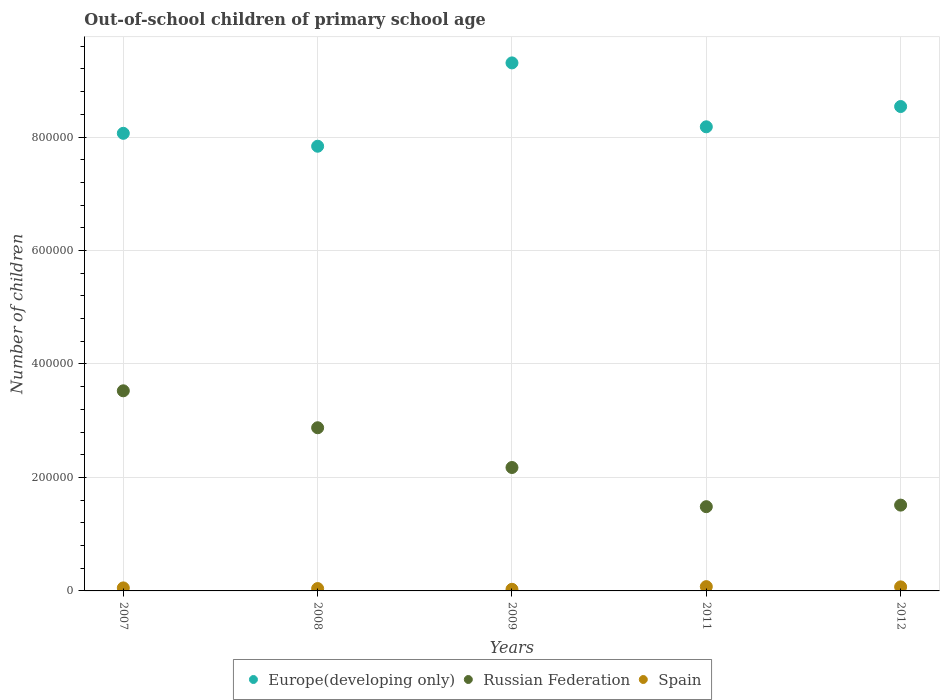How many different coloured dotlines are there?
Provide a short and direct response. 3. What is the number of out-of-school children in Russian Federation in 2007?
Give a very brief answer. 3.53e+05. Across all years, what is the maximum number of out-of-school children in Spain?
Your response must be concise. 7575. Across all years, what is the minimum number of out-of-school children in Spain?
Give a very brief answer. 2853. In which year was the number of out-of-school children in Europe(developing only) maximum?
Your response must be concise. 2009. In which year was the number of out-of-school children in Russian Federation minimum?
Make the answer very short. 2011. What is the total number of out-of-school children in Europe(developing only) in the graph?
Keep it short and to the point. 4.19e+06. What is the difference between the number of out-of-school children in Russian Federation in 2007 and that in 2012?
Your answer should be very brief. 2.01e+05. What is the difference between the number of out-of-school children in Russian Federation in 2009 and the number of out-of-school children in Spain in 2012?
Offer a terse response. 2.10e+05. What is the average number of out-of-school children in Russian Federation per year?
Offer a terse response. 2.32e+05. In the year 2012, what is the difference between the number of out-of-school children in Spain and number of out-of-school children in Russian Federation?
Give a very brief answer. -1.44e+05. In how many years, is the number of out-of-school children in Spain greater than 840000?
Your answer should be compact. 0. What is the ratio of the number of out-of-school children in Spain in 2008 to that in 2011?
Provide a short and direct response. 0.55. Is the number of out-of-school children in Russian Federation in 2009 less than that in 2011?
Your answer should be very brief. No. Is the difference between the number of out-of-school children in Spain in 2008 and 2012 greater than the difference between the number of out-of-school children in Russian Federation in 2008 and 2012?
Your answer should be very brief. No. What is the difference between the highest and the second highest number of out-of-school children in Russian Federation?
Ensure brevity in your answer.  6.51e+04. What is the difference between the highest and the lowest number of out-of-school children in Europe(developing only)?
Keep it short and to the point. 1.47e+05. In how many years, is the number of out-of-school children in Russian Federation greater than the average number of out-of-school children in Russian Federation taken over all years?
Keep it short and to the point. 2. Does the number of out-of-school children in Russian Federation monotonically increase over the years?
Your response must be concise. No. Is the number of out-of-school children in Russian Federation strictly greater than the number of out-of-school children in Spain over the years?
Keep it short and to the point. Yes. Is the number of out-of-school children in Europe(developing only) strictly less than the number of out-of-school children in Russian Federation over the years?
Your response must be concise. No. Are the values on the major ticks of Y-axis written in scientific E-notation?
Keep it short and to the point. No. Does the graph contain any zero values?
Your answer should be compact. No. How are the legend labels stacked?
Offer a very short reply. Horizontal. What is the title of the graph?
Your answer should be compact. Out-of-school children of primary school age. What is the label or title of the X-axis?
Offer a terse response. Years. What is the label or title of the Y-axis?
Offer a terse response. Number of children. What is the Number of children in Europe(developing only) in 2007?
Offer a very short reply. 8.07e+05. What is the Number of children in Russian Federation in 2007?
Provide a succinct answer. 3.53e+05. What is the Number of children of Spain in 2007?
Offer a terse response. 5316. What is the Number of children of Europe(developing only) in 2008?
Your answer should be compact. 7.84e+05. What is the Number of children in Russian Federation in 2008?
Provide a short and direct response. 2.88e+05. What is the Number of children of Spain in 2008?
Your answer should be very brief. 4170. What is the Number of children in Europe(developing only) in 2009?
Make the answer very short. 9.31e+05. What is the Number of children of Russian Federation in 2009?
Offer a terse response. 2.18e+05. What is the Number of children in Spain in 2009?
Offer a very short reply. 2853. What is the Number of children of Europe(developing only) in 2011?
Provide a succinct answer. 8.18e+05. What is the Number of children in Russian Federation in 2011?
Give a very brief answer. 1.48e+05. What is the Number of children of Spain in 2011?
Ensure brevity in your answer.  7575. What is the Number of children in Europe(developing only) in 2012?
Make the answer very short. 8.54e+05. What is the Number of children of Russian Federation in 2012?
Offer a very short reply. 1.51e+05. What is the Number of children of Spain in 2012?
Provide a short and direct response. 7116. Across all years, what is the maximum Number of children in Europe(developing only)?
Keep it short and to the point. 9.31e+05. Across all years, what is the maximum Number of children of Russian Federation?
Your answer should be very brief. 3.53e+05. Across all years, what is the maximum Number of children in Spain?
Provide a succinct answer. 7575. Across all years, what is the minimum Number of children in Europe(developing only)?
Give a very brief answer. 7.84e+05. Across all years, what is the minimum Number of children in Russian Federation?
Provide a short and direct response. 1.48e+05. Across all years, what is the minimum Number of children in Spain?
Provide a succinct answer. 2853. What is the total Number of children in Europe(developing only) in the graph?
Make the answer very short. 4.19e+06. What is the total Number of children in Russian Federation in the graph?
Offer a terse response. 1.16e+06. What is the total Number of children in Spain in the graph?
Keep it short and to the point. 2.70e+04. What is the difference between the Number of children of Europe(developing only) in 2007 and that in 2008?
Offer a very short reply. 2.28e+04. What is the difference between the Number of children in Russian Federation in 2007 and that in 2008?
Ensure brevity in your answer.  6.51e+04. What is the difference between the Number of children in Spain in 2007 and that in 2008?
Offer a terse response. 1146. What is the difference between the Number of children of Europe(developing only) in 2007 and that in 2009?
Ensure brevity in your answer.  -1.24e+05. What is the difference between the Number of children of Russian Federation in 2007 and that in 2009?
Offer a very short reply. 1.35e+05. What is the difference between the Number of children in Spain in 2007 and that in 2009?
Provide a short and direct response. 2463. What is the difference between the Number of children of Europe(developing only) in 2007 and that in 2011?
Your response must be concise. -1.15e+04. What is the difference between the Number of children of Russian Federation in 2007 and that in 2011?
Give a very brief answer. 2.04e+05. What is the difference between the Number of children in Spain in 2007 and that in 2011?
Offer a very short reply. -2259. What is the difference between the Number of children in Europe(developing only) in 2007 and that in 2012?
Offer a very short reply. -4.72e+04. What is the difference between the Number of children of Russian Federation in 2007 and that in 2012?
Provide a succinct answer. 2.01e+05. What is the difference between the Number of children in Spain in 2007 and that in 2012?
Make the answer very short. -1800. What is the difference between the Number of children in Europe(developing only) in 2008 and that in 2009?
Make the answer very short. -1.47e+05. What is the difference between the Number of children in Russian Federation in 2008 and that in 2009?
Your answer should be compact. 7.01e+04. What is the difference between the Number of children in Spain in 2008 and that in 2009?
Offer a terse response. 1317. What is the difference between the Number of children of Europe(developing only) in 2008 and that in 2011?
Your answer should be very brief. -3.42e+04. What is the difference between the Number of children of Russian Federation in 2008 and that in 2011?
Give a very brief answer. 1.39e+05. What is the difference between the Number of children in Spain in 2008 and that in 2011?
Provide a succinct answer. -3405. What is the difference between the Number of children of Europe(developing only) in 2008 and that in 2012?
Keep it short and to the point. -7.00e+04. What is the difference between the Number of children of Russian Federation in 2008 and that in 2012?
Your response must be concise. 1.36e+05. What is the difference between the Number of children of Spain in 2008 and that in 2012?
Make the answer very short. -2946. What is the difference between the Number of children of Europe(developing only) in 2009 and that in 2011?
Give a very brief answer. 1.13e+05. What is the difference between the Number of children in Russian Federation in 2009 and that in 2011?
Your answer should be compact. 6.90e+04. What is the difference between the Number of children in Spain in 2009 and that in 2011?
Ensure brevity in your answer.  -4722. What is the difference between the Number of children in Europe(developing only) in 2009 and that in 2012?
Your answer should be very brief. 7.69e+04. What is the difference between the Number of children in Russian Federation in 2009 and that in 2012?
Ensure brevity in your answer.  6.63e+04. What is the difference between the Number of children of Spain in 2009 and that in 2012?
Offer a very short reply. -4263. What is the difference between the Number of children in Europe(developing only) in 2011 and that in 2012?
Your answer should be very brief. -3.57e+04. What is the difference between the Number of children of Russian Federation in 2011 and that in 2012?
Offer a terse response. -2750. What is the difference between the Number of children of Spain in 2011 and that in 2012?
Provide a short and direct response. 459. What is the difference between the Number of children in Europe(developing only) in 2007 and the Number of children in Russian Federation in 2008?
Your answer should be very brief. 5.19e+05. What is the difference between the Number of children in Europe(developing only) in 2007 and the Number of children in Spain in 2008?
Offer a terse response. 8.02e+05. What is the difference between the Number of children in Russian Federation in 2007 and the Number of children in Spain in 2008?
Offer a very short reply. 3.49e+05. What is the difference between the Number of children in Europe(developing only) in 2007 and the Number of children in Russian Federation in 2009?
Give a very brief answer. 5.89e+05. What is the difference between the Number of children of Europe(developing only) in 2007 and the Number of children of Spain in 2009?
Offer a very short reply. 8.04e+05. What is the difference between the Number of children in Russian Federation in 2007 and the Number of children in Spain in 2009?
Offer a very short reply. 3.50e+05. What is the difference between the Number of children in Europe(developing only) in 2007 and the Number of children in Russian Federation in 2011?
Keep it short and to the point. 6.58e+05. What is the difference between the Number of children of Europe(developing only) in 2007 and the Number of children of Spain in 2011?
Offer a very short reply. 7.99e+05. What is the difference between the Number of children in Russian Federation in 2007 and the Number of children in Spain in 2011?
Provide a short and direct response. 3.45e+05. What is the difference between the Number of children of Europe(developing only) in 2007 and the Number of children of Russian Federation in 2012?
Offer a very short reply. 6.55e+05. What is the difference between the Number of children in Europe(developing only) in 2007 and the Number of children in Spain in 2012?
Ensure brevity in your answer.  7.99e+05. What is the difference between the Number of children of Russian Federation in 2007 and the Number of children of Spain in 2012?
Provide a succinct answer. 3.46e+05. What is the difference between the Number of children of Europe(developing only) in 2008 and the Number of children of Russian Federation in 2009?
Provide a succinct answer. 5.66e+05. What is the difference between the Number of children of Europe(developing only) in 2008 and the Number of children of Spain in 2009?
Provide a succinct answer. 7.81e+05. What is the difference between the Number of children in Russian Federation in 2008 and the Number of children in Spain in 2009?
Provide a short and direct response. 2.85e+05. What is the difference between the Number of children of Europe(developing only) in 2008 and the Number of children of Russian Federation in 2011?
Make the answer very short. 6.35e+05. What is the difference between the Number of children of Europe(developing only) in 2008 and the Number of children of Spain in 2011?
Offer a terse response. 7.76e+05. What is the difference between the Number of children in Russian Federation in 2008 and the Number of children in Spain in 2011?
Make the answer very short. 2.80e+05. What is the difference between the Number of children of Europe(developing only) in 2008 and the Number of children of Russian Federation in 2012?
Provide a succinct answer. 6.33e+05. What is the difference between the Number of children in Europe(developing only) in 2008 and the Number of children in Spain in 2012?
Offer a terse response. 7.77e+05. What is the difference between the Number of children of Russian Federation in 2008 and the Number of children of Spain in 2012?
Your response must be concise. 2.81e+05. What is the difference between the Number of children in Europe(developing only) in 2009 and the Number of children in Russian Federation in 2011?
Offer a very short reply. 7.82e+05. What is the difference between the Number of children in Europe(developing only) in 2009 and the Number of children in Spain in 2011?
Ensure brevity in your answer.  9.23e+05. What is the difference between the Number of children in Russian Federation in 2009 and the Number of children in Spain in 2011?
Make the answer very short. 2.10e+05. What is the difference between the Number of children in Europe(developing only) in 2009 and the Number of children in Russian Federation in 2012?
Offer a very short reply. 7.79e+05. What is the difference between the Number of children of Europe(developing only) in 2009 and the Number of children of Spain in 2012?
Make the answer very short. 9.24e+05. What is the difference between the Number of children of Russian Federation in 2009 and the Number of children of Spain in 2012?
Provide a short and direct response. 2.10e+05. What is the difference between the Number of children in Europe(developing only) in 2011 and the Number of children in Russian Federation in 2012?
Provide a short and direct response. 6.67e+05. What is the difference between the Number of children of Europe(developing only) in 2011 and the Number of children of Spain in 2012?
Provide a short and direct response. 8.11e+05. What is the difference between the Number of children of Russian Federation in 2011 and the Number of children of Spain in 2012?
Your answer should be very brief. 1.41e+05. What is the average Number of children of Europe(developing only) per year?
Offer a very short reply. 8.39e+05. What is the average Number of children of Russian Federation per year?
Offer a very short reply. 2.32e+05. What is the average Number of children of Spain per year?
Your answer should be very brief. 5406. In the year 2007, what is the difference between the Number of children of Europe(developing only) and Number of children of Russian Federation?
Give a very brief answer. 4.54e+05. In the year 2007, what is the difference between the Number of children in Europe(developing only) and Number of children in Spain?
Ensure brevity in your answer.  8.01e+05. In the year 2007, what is the difference between the Number of children of Russian Federation and Number of children of Spain?
Give a very brief answer. 3.47e+05. In the year 2008, what is the difference between the Number of children of Europe(developing only) and Number of children of Russian Federation?
Make the answer very short. 4.96e+05. In the year 2008, what is the difference between the Number of children in Europe(developing only) and Number of children in Spain?
Your answer should be compact. 7.80e+05. In the year 2008, what is the difference between the Number of children of Russian Federation and Number of children of Spain?
Your answer should be compact. 2.83e+05. In the year 2009, what is the difference between the Number of children of Europe(developing only) and Number of children of Russian Federation?
Your answer should be compact. 7.13e+05. In the year 2009, what is the difference between the Number of children in Europe(developing only) and Number of children in Spain?
Your answer should be compact. 9.28e+05. In the year 2009, what is the difference between the Number of children in Russian Federation and Number of children in Spain?
Provide a succinct answer. 2.15e+05. In the year 2011, what is the difference between the Number of children in Europe(developing only) and Number of children in Russian Federation?
Your answer should be compact. 6.70e+05. In the year 2011, what is the difference between the Number of children of Europe(developing only) and Number of children of Spain?
Give a very brief answer. 8.10e+05. In the year 2011, what is the difference between the Number of children of Russian Federation and Number of children of Spain?
Offer a terse response. 1.41e+05. In the year 2012, what is the difference between the Number of children in Europe(developing only) and Number of children in Russian Federation?
Ensure brevity in your answer.  7.03e+05. In the year 2012, what is the difference between the Number of children of Europe(developing only) and Number of children of Spain?
Provide a succinct answer. 8.47e+05. In the year 2012, what is the difference between the Number of children in Russian Federation and Number of children in Spain?
Give a very brief answer. 1.44e+05. What is the ratio of the Number of children in Russian Federation in 2007 to that in 2008?
Offer a very short reply. 1.23. What is the ratio of the Number of children in Spain in 2007 to that in 2008?
Give a very brief answer. 1.27. What is the ratio of the Number of children of Europe(developing only) in 2007 to that in 2009?
Your answer should be compact. 0.87. What is the ratio of the Number of children of Russian Federation in 2007 to that in 2009?
Offer a terse response. 1.62. What is the ratio of the Number of children of Spain in 2007 to that in 2009?
Provide a short and direct response. 1.86. What is the ratio of the Number of children of Europe(developing only) in 2007 to that in 2011?
Your answer should be compact. 0.99. What is the ratio of the Number of children in Russian Federation in 2007 to that in 2011?
Give a very brief answer. 2.38. What is the ratio of the Number of children in Spain in 2007 to that in 2011?
Your answer should be very brief. 0.7. What is the ratio of the Number of children in Europe(developing only) in 2007 to that in 2012?
Ensure brevity in your answer.  0.94. What is the ratio of the Number of children of Russian Federation in 2007 to that in 2012?
Provide a short and direct response. 2.33. What is the ratio of the Number of children in Spain in 2007 to that in 2012?
Give a very brief answer. 0.75. What is the ratio of the Number of children of Europe(developing only) in 2008 to that in 2009?
Offer a very short reply. 0.84. What is the ratio of the Number of children in Russian Federation in 2008 to that in 2009?
Give a very brief answer. 1.32. What is the ratio of the Number of children in Spain in 2008 to that in 2009?
Make the answer very short. 1.46. What is the ratio of the Number of children of Europe(developing only) in 2008 to that in 2011?
Provide a succinct answer. 0.96. What is the ratio of the Number of children of Russian Federation in 2008 to that in 2011?
Give a very brief answer. 1.94. What is the ratio of the Number of children of Spain in 2008 to that in 2011?
Your answer should be very brief. 0.55. What is the ratio of the Number of children in Europe(developing only) in 2008 to that in 2012?
Give a very brief answer. 0.92. What is the ratio of the Number of children of Russian Federation in 2008 to that in 2012?
Provide a short and direct response. 1.9. What is the ratio of the Number of children in Spain in 2008 to that in 2012?
Keep it short and to the point. 0.59. What is the ratio of the Number of children of Europe(developing only) in 2009 to that in 2011?
Offer a terse response. 1.14. What is the ratio of the Number of children of Russian Federation in 2009 to that in 2011?
Your answer should be compact. 1.47. What is the ratio of the Number of children in Spain in 2009 to that in 2011?
Give a very brief answer. 0.38. What is the ratio of the Number of children in Europe(developing only) in 2009 to that in 2012?
Keep it short and to the point. 1.09. What is the ratio of the Number of children of Russian Federation in 2009 to that in 2012?
Provide a short and direct response. 1.44. What is the ratio of the Number of children in Spain in 2009 to that in 2012?
Offer a very short reply. 0.4. What is the ratio of the Number of children in Europe(developing only) in 2011 to that in 2012?
Your answer should be very brief. 0.96. What is the ratio of the Number of children in Russian Federation in 2011 to that in 2012?
Give a very brief answer. 0.98. What is the ratio of the Number of children in Spain in 2011 to that in 2012?
Provide a short and direct response. 1.06. What is the difference between the highest and the second highest Number of children in Europe(developing only)?
Keep it short and to the point. 7.69e+04. What is the difference between the highest and the second highest Number of children of Russian Federation?
Give a very brief answer. 6.51e+04. What is the difference between the highest and the second highest Number of children in Spain?
Give a very brief answer. 459. What is the difference between the highest and the lowest Number of children of Europe(developing only)?
Keep it short and to the point. 1.47e+05. What is the difference between the highest and the lowest Number of children in Russian Federation?
Ensure brevity in your answer.  2.04e+05. What is the difference between the highest and the lowest Number of children in Spain?
Give a very brief answer. 4722. 